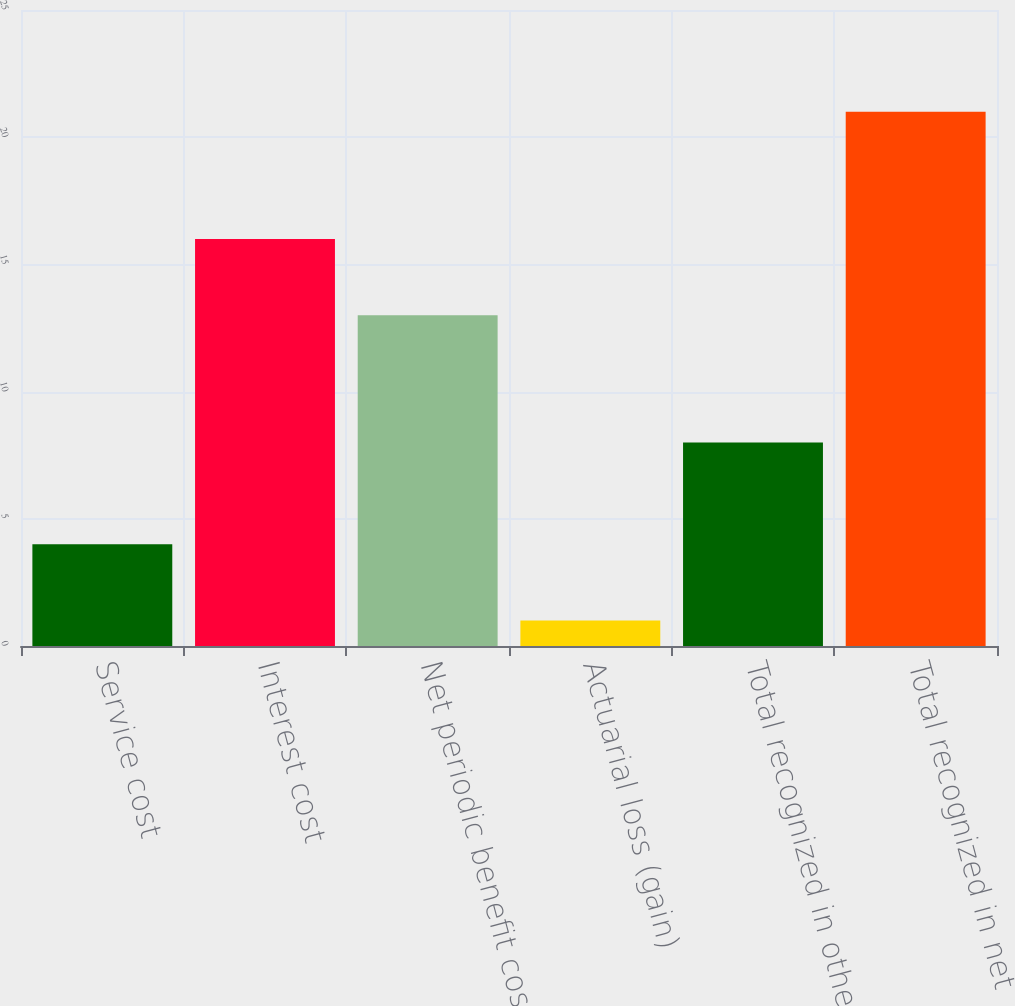<chart> <loc_0><loc_0><loc_500><loc_500><bar_chart><fcel>Service cost<fcel>Interest cost<fcel>Net periodic benefit cost (b)<fcel>Actuarial loss (gain)<fcel>Total recognized in other<fcel>Total recognized in net<nl><fcel>4<fcel>16<fcel>13<fcel>1<fcel>8<fcel>21<nl></chart> 